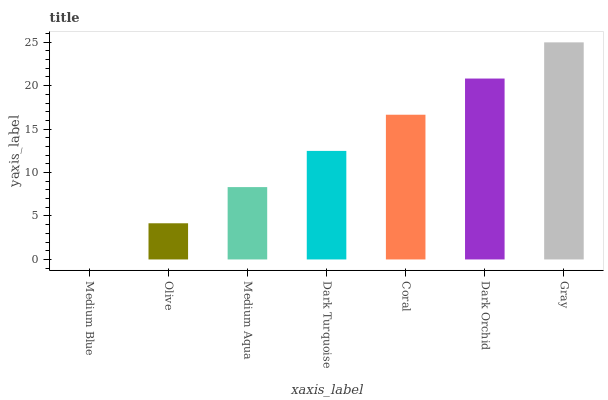Is Medium Blue the minimum?
Answer yes or no. Yes. Is Gray the maximum?
Answer yes or no. Yes. Is Olive the minimum?
Answer yes or no. No. Is Olive the maximum?
Answer yes or no. No. Is Olive greater than Medium Blue?
Answer yes or no. Yes. Is Medium Blue less than Olive?
Answer yes or no. Yes. Is Medium Blue greater than Olive?
Answer yes or no. No. Is Olive less than Medium Blue?
Answer yes or no. No. Is Dark Turquoise the high median?
Answer yes or no. Yes. Is Dark Turquoise the low median?
Answer yes or no. Yes. Is Olive the high median?
Answer yes or no. No. Is Coral the low median?
Answer yes or no. No. 